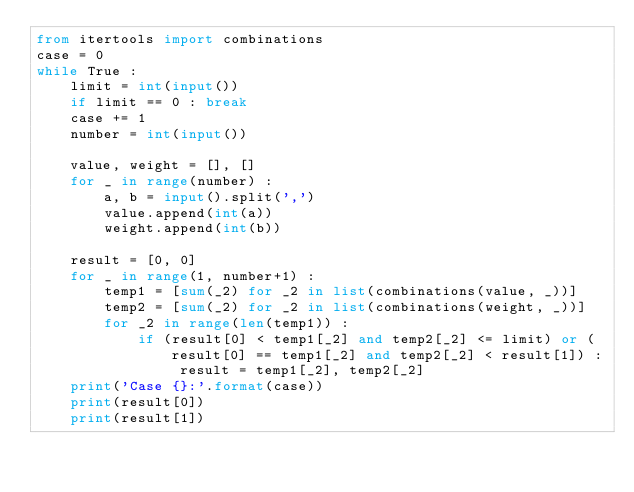<code> <loc_0><loc_0><loc_500><loc_500><_Python_>from itertools import combinations
case = 0
while True :
    limit = int(input())
    if limit == 0 : break
    case += 1
    number = int(input())
    
    value, weight = [], []
    for _ in range(number) :
        a, b = input().split(',')
        value.append(int(a))
        weight.append(int(b))
    
    result = [0, 0]
    for _ in range(1, number+1) :
        temp1 = [sum(_2) for _2 in list(combinations(value, _))]
        temp2 = [sum(_2) for _2 in list(combinations(weight, _))]
        for _2 in range(len(temp1)) :
            if (result[0] < temp1[_2] and temp2[_2] <= limit) or (result[0] == temp1[_2] and temp2[_2] < result[1]) : result = temp1[_2], temp2[_2]
    print('Case {}:'.format(case))
    print(result[0])
    print(result[1])</code> 